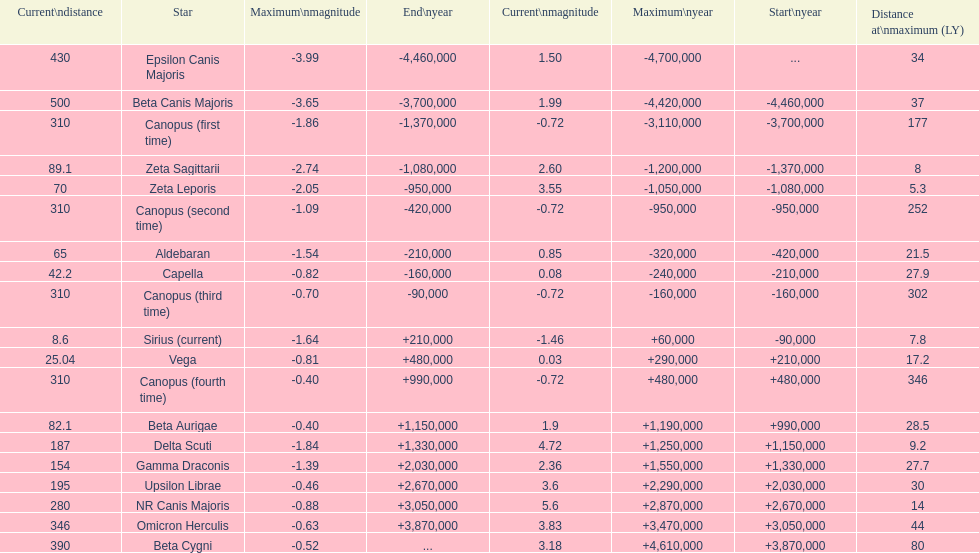What is the only star with a distance at maximum of 80? Beta Cygni. 